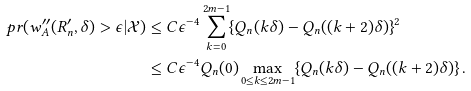Convert formula to latex. <formula><loc_0><loc_0><loc_500><loc_500>\ p r ( w _ { A } ^ { \prime \prime } ( R _ { n } ^ { \prime } , \delta ) > \epsilon | \mathcal { X } ) & \leq C \epsilon ^ { - 4 } \sum _ { k = 0 } ^ { 2 m - 1 } \{ Q _ { n } ( k \delta ) - Q _ { n } ( ( k + 2 ) \delta ) \} ^ { 2 } \\ & \leq C \epsilon ^ { - 4 } Q _ { n } ( 0 ) \max _ { 0 \leq k \leq 2 m - 1 } \{ Q _ { n } ( k \delta ) - Q _ { n } ( ( k + 2 ) \delta ) \} \, .</formula> 